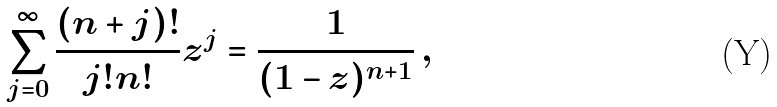<formula> <loc_0><loc_0><loc_500><loc_500>\sum _ { j = 0 } ^ { \infty } \frac { ( n + j ) ! } { j ! n ! } z ^ { j } = \frac { 1 } { ( 1 - z ) ^ { n + 1 } } \, ,</formula> 